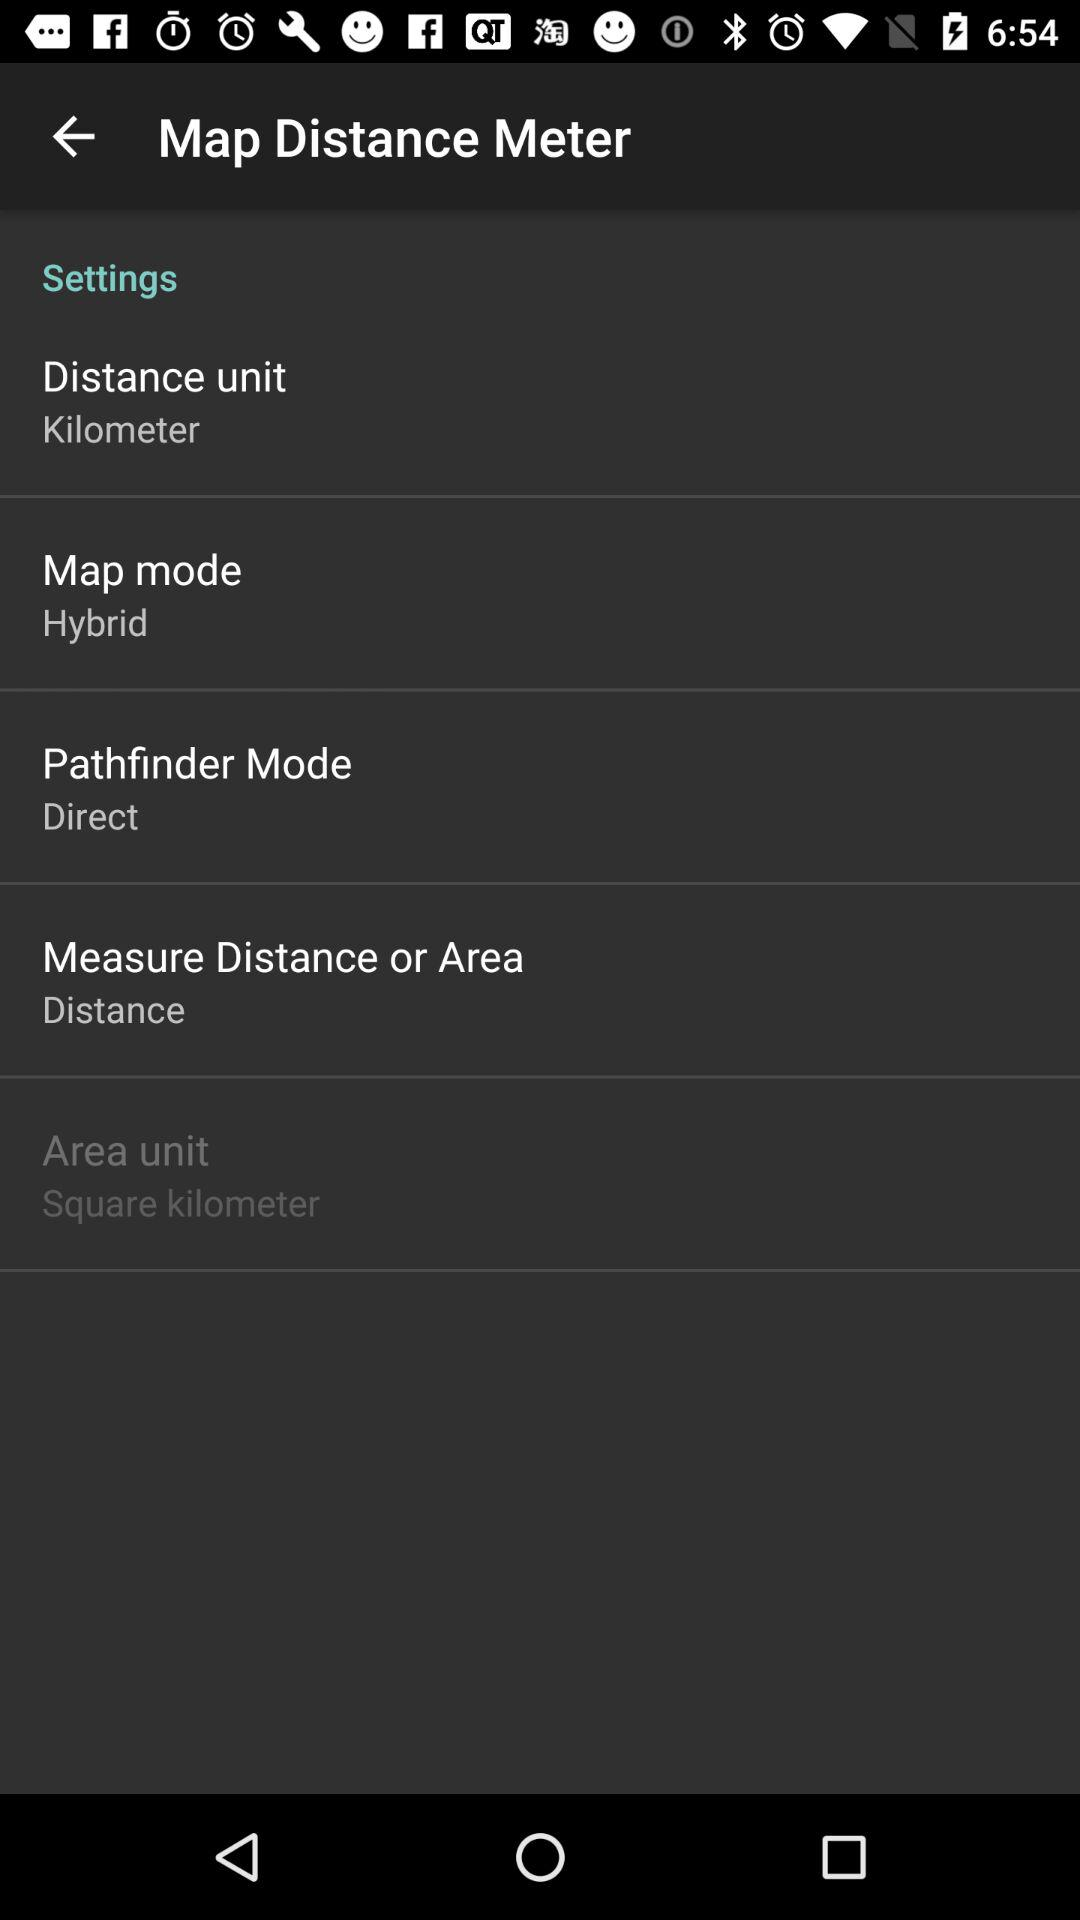What is the shown map mode? The shown map mode is "Hybrid". 